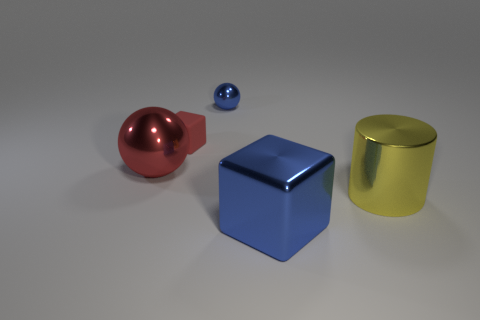What is the size of the blue object that is the same material as the big cube?
Your response must be concise. Small. Do the metallic sphere that is on the right side of the large red ball and the block that is in front of the big red ball have the same size?
Offer a very short reply. No. Is the color of the small cube the same as the big metallic object on the left side of the blue cube?
Keep it short and to the point. Yes. Are there fewer red shiny balls that are on the right side of the small red matte block than large shiny things?
Make the answer very short. Yes. What number of other things are there of the same size as the matte object?
Keep it short and to the point. 1. There is a blue thing right of the small blue sphere; does it have the same shape as the tiny red matte thing?
Your answer should be very brief. Yes. Is the number of blue shiny objects in front of the large red thing greater than the number of small green shiny cylinders?
Your answer should be compact. Yes. What is the material of the big object that is both on the right side of the small blue metal object and on the left side of the yellow object?
Make the answer very short. Metal. Is there anything else that is the same shape as the large yellow metal object?
Give a very brief answer. No. How many big objects are right of the large blue block and left of the blue metal sphere?
Give a very brief answer. 0. 